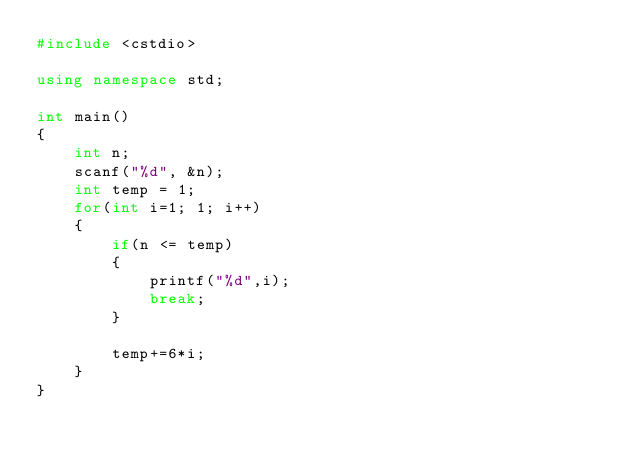Convert code to text. <code><loc_0><loc_0><loc_500><loc_500><_C++_>#include <cstdio>

using namespace std;

int main()
{
    int n;
    scanf("%d", &n);
    int temp = 1;
    for(int i=1; 1; i++)
    {
        if(n <= temp)
        {
            printf("%d",i);
            break;
        }

        temp+=6*i;
    }
}</code> 